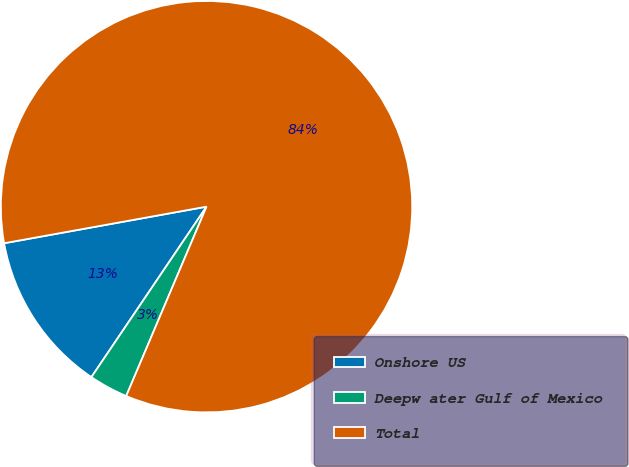Convert chart. <chart><loc_0><loc_0><loc_500><loc_500><pie_chart><fcel>Onshore US<fcel>Deepw ater Gulf of Mexico<fcel>Total<nl><fcel>12.7%<fcel>3.07%<fcel>84.23%<nl></chart> 